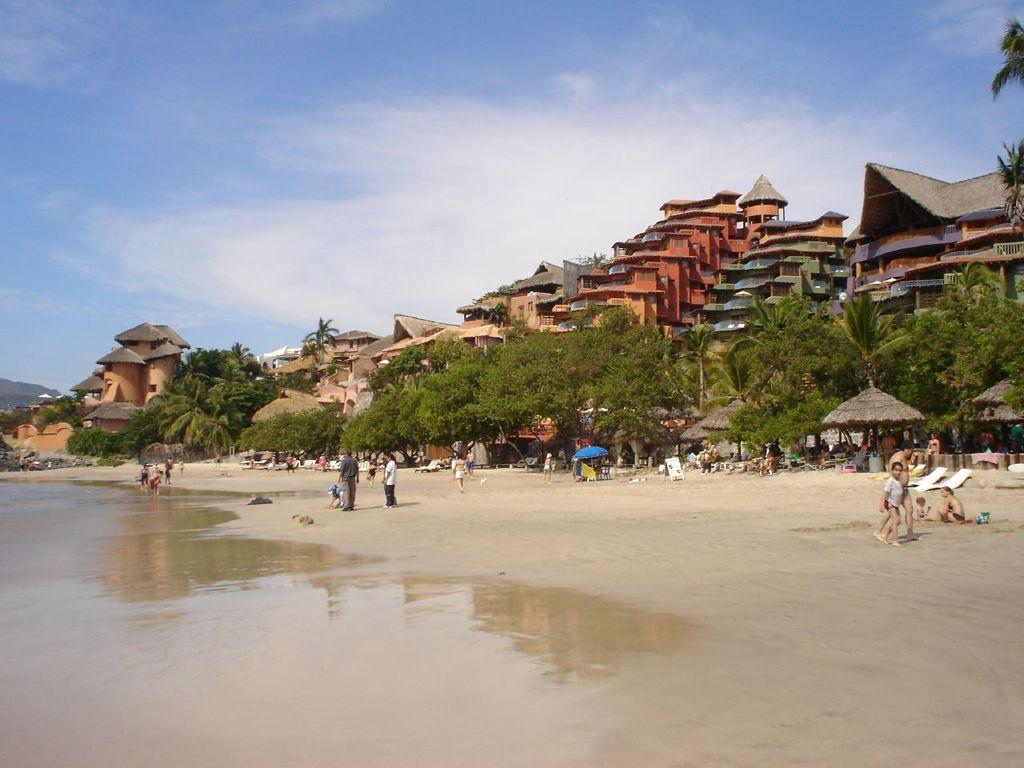How many people can be seen in the image? There are people in the image, but the exact number is not specified. What is the primary natural element visible in the image? Water is visible in the image, along with sand. What type of structures are present in the image? There are huts, a board, trees, and buildings in the image. What is being used for shade in the image? There is an umbrella in the image for shade. What else can be seen in the image besides the people and structures? There are objects in the image, but their specific nature is not mentioned. What is visible in the background of the image? The sky is visible in the background of the image. How many vases can be seen in the image? There is no mention of vases in the image, so it is not possible to determine their presence or quantity. What type of lizards can be seen in the image? There is no mention of lizards in the image, so it is not possible to determine their presence or type. 